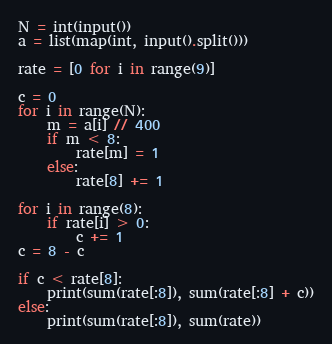<code> <loc_0><loc_0><loc_500><loc_500><_Python_>N = int(input())
a = list(map(int, input().split()))

rate = [0 for i in range(9)]

c = 0
for i in range(N):
    m = a[i] // 400
    if m < 8:
        rate[m] = 1
    else:
        rate[8] += 1

for i in range(8):
    if rate[i] > 0:
        c += 1
c = 8 - c

if c < rate[8]:
    print(sum(rate[:8]), sum(rate[:8] + c))
else:
    print(sum(rate[:8]), sum(rate))
</code> 